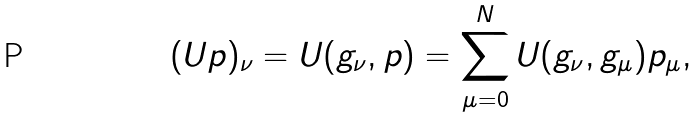<formula> <loc_0><loc_0><loc_500><loc_500>( U p ) _ { \nu } = U ( g _ { \nu } , p ) = \sum _ { \mu = 0 } ^ { N } U ( g _ { \nu } , g _ { \mu } ) p _ { \mu } ,</formula> 